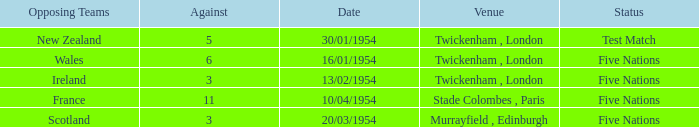What is the lowest against for games played in the stade colombes, paris venue? 11.0. 